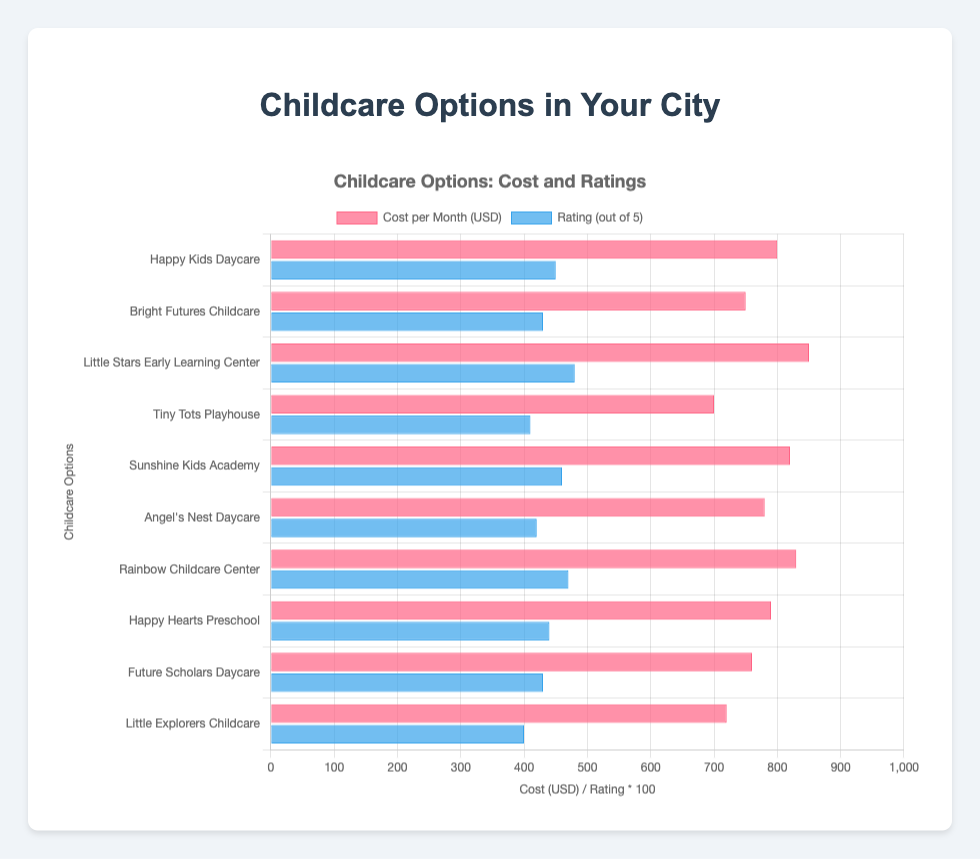Which childcare option has the highest rating? Look for the bar representing the highest rating (blue color). "Little Stars Early Learning Center" has the highest rating of 4.8 out of 5.
Answer: Little Stars Early Learning Center What is the average monthly cost of the top three highest-rated childcare options? Identify the three highest-rated options: Little Stars Early Learning Center (850 USD), Rainbow Childcare Center (830 USD), and Sunshine Kids Academy (820 USD). Average cost = (850 + 830 + 820) / 3 = 2500 / 3 = 833.33 USD.
Answer: 833.33 USD Which childcare option offers the lowest cost per month? Look at the bars representing cost per month (red color) and identify the shortest one. "Tiny Tots Playhouse" has the lowest cost of 700 USD per month.
Answer: Tiny Tots Playhouse Compare the ratings of "Happy Kids Daycare" and "Bright Futures Childcare." Which one has a higher rating? Check the bar heights for these two options in blue color. Happy Kids Daycare has a rating of 4.5, while Bright Futures Childcare has a rating of 4.3.
Answer: Happy Kids Daycare How much more expensive is "Little Stars Early Learning Center" compared to "Tiny Tots Playhouse"? Compare the costs: Little Stars Early Learning Center (850 USD) - Tiny Tots Playhouse (700 USD). The difference is 150 USD.
Answer: 150 USD If I want a childcare option with a rating of at least 4.5 and a cost of no more than 800 USD, which options should I consider? Check the criteria: "Happy Kids Daycare" meets both criteria with a rating of 4.5 and cost of 800 USD.
Answer: Happy Kids Daycare What is the range of costs per month among all childcare options? Identify the highest and lowest costs: the highest is 850 USD (Little Stars Early Learning Center) and the lowest is 700 USD (Tiny Tots Playhouse). Range = 850 - 700 = 150 USD.
Answer: 150 USD How does the cost of "Happy Hearts Preschool" compare to its rating? Look at the respective bars for Happy Hearts Preschool: cost is 790 USD, and rating is 4.4.
Answer: Cost: 790 USD, Rating: 4.4 Which childcare option has the closest cost to 800 USD but has a rating below 4.5? Identify costs near 800 USD: "Angel's Nest Daycare" (780 USD, rating 4.2) and "Future Scholars Daycare" (760 USD, rating 4.3) are close.
Answer: Angel's Nest Daycare and Future Scholars Daycare 